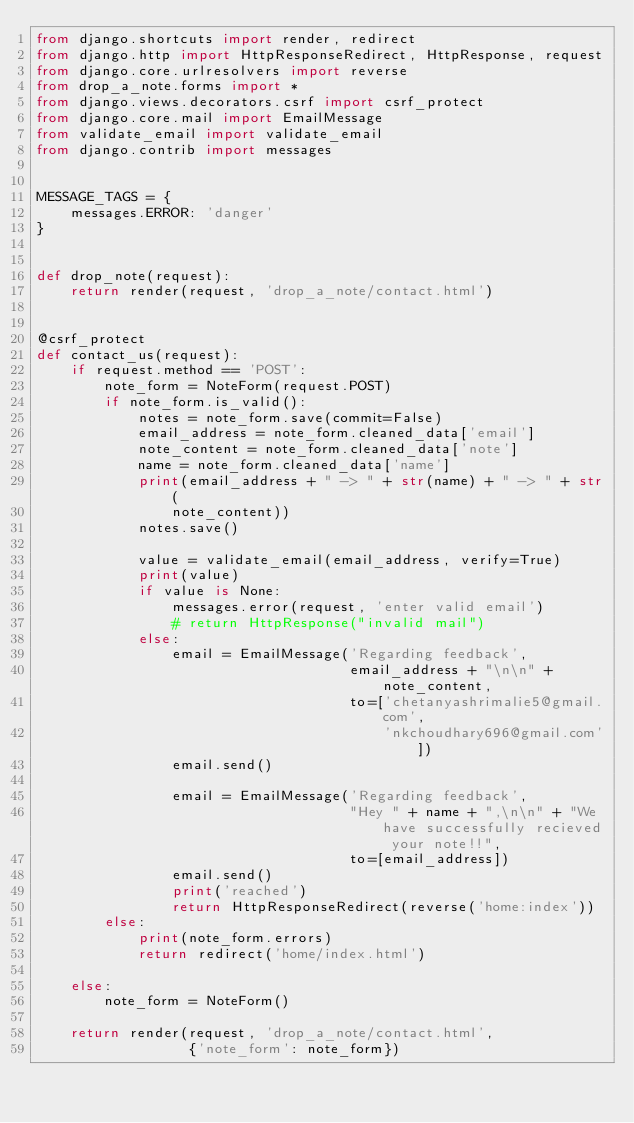Convert code to text. <code><loc_0><loc_0><loc_500><loc_500><_Python_>from django.shortcuts import render, redirect
from django.http import HttpResponseRedirect, HttpResponse, request
from django.core.urlresolvers import reverse
from drop_a_note.forms import *
from django.views.decorators.csrf import csrf_protect
from django.core.mail import EmailMessage
from validate_email import validate_email
from django.contrib import messages


MESSAGE_TAGS = {
    messages.ERROR: 'danger'
}


def drop_note(request):
    return render(request, 'drop_a_note/contact.html')


@csrf_protect
def contact_us(request):
    if request.method == 'POST':
        note_form = NoteForm(request.POST)
        if note_form.is_valid():
            notes = note_form.save(commit=False)
            email_address = note_form.cleaned_data['email']
            note_content = note_form.cleaned_data['note']
            name = note_form.cleaned_data['name']
            print(email_address + " -> " + str(name) + " -> " + str(
                note_content))
            notes.save()

            value = validate_email(email_address, verify=True)
            print(value)
            if value is None:
                messages.error(request, 'enter valid email')
                # return HttpResponse("invalid mail")
            else:
                email = EmailMessage('Regarding feedback',
                                     email_address + "\n\n" + note_content,
                                     to=['chetanyashrimalie5@gmail.com',
                                         'nkchoudhary696@gmail.com'])
                email.send()
    
                email = EmailMessage('Regarding feedback',
                                     "Hey " + name + ",\n\n" + "We have successfully recieved your note!!",
                                     to=[email_address])
                email.send()
                print('reached')
                return HttpResponseRedirect(reverse('home:index'))
        else:
            print(note_form.errors)
            return redirect('home/index.html')

    else:
        note_form = NoteForm()

    return render(request, 'drop_a_note/contact.html',
                  {'note_form': note_form})
</code> 